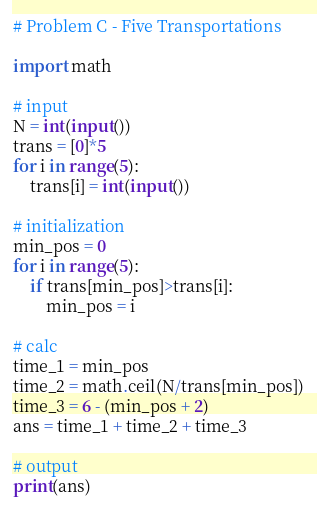Convert code to text. <code><loc_0><loc_0><loc_500><loc_500><_Python_># Problem C - Five Transportations

import math

# input
N = int(input())
trans = [0]*5
for i in range(5):
    trans[i] = int(input())

# initialization
min_pos = 0
for i in range(5):
    if trans[min_pos]>trans[i]:
        min_pos = i

# calc
time_1 = min_pos
time_2 = math.ceil(N/trans[min_pos])
time_3 = 6 - (min_pos + 2)
ans = time_1 + time_2 + time_3

# output
print(ans)
</code> 